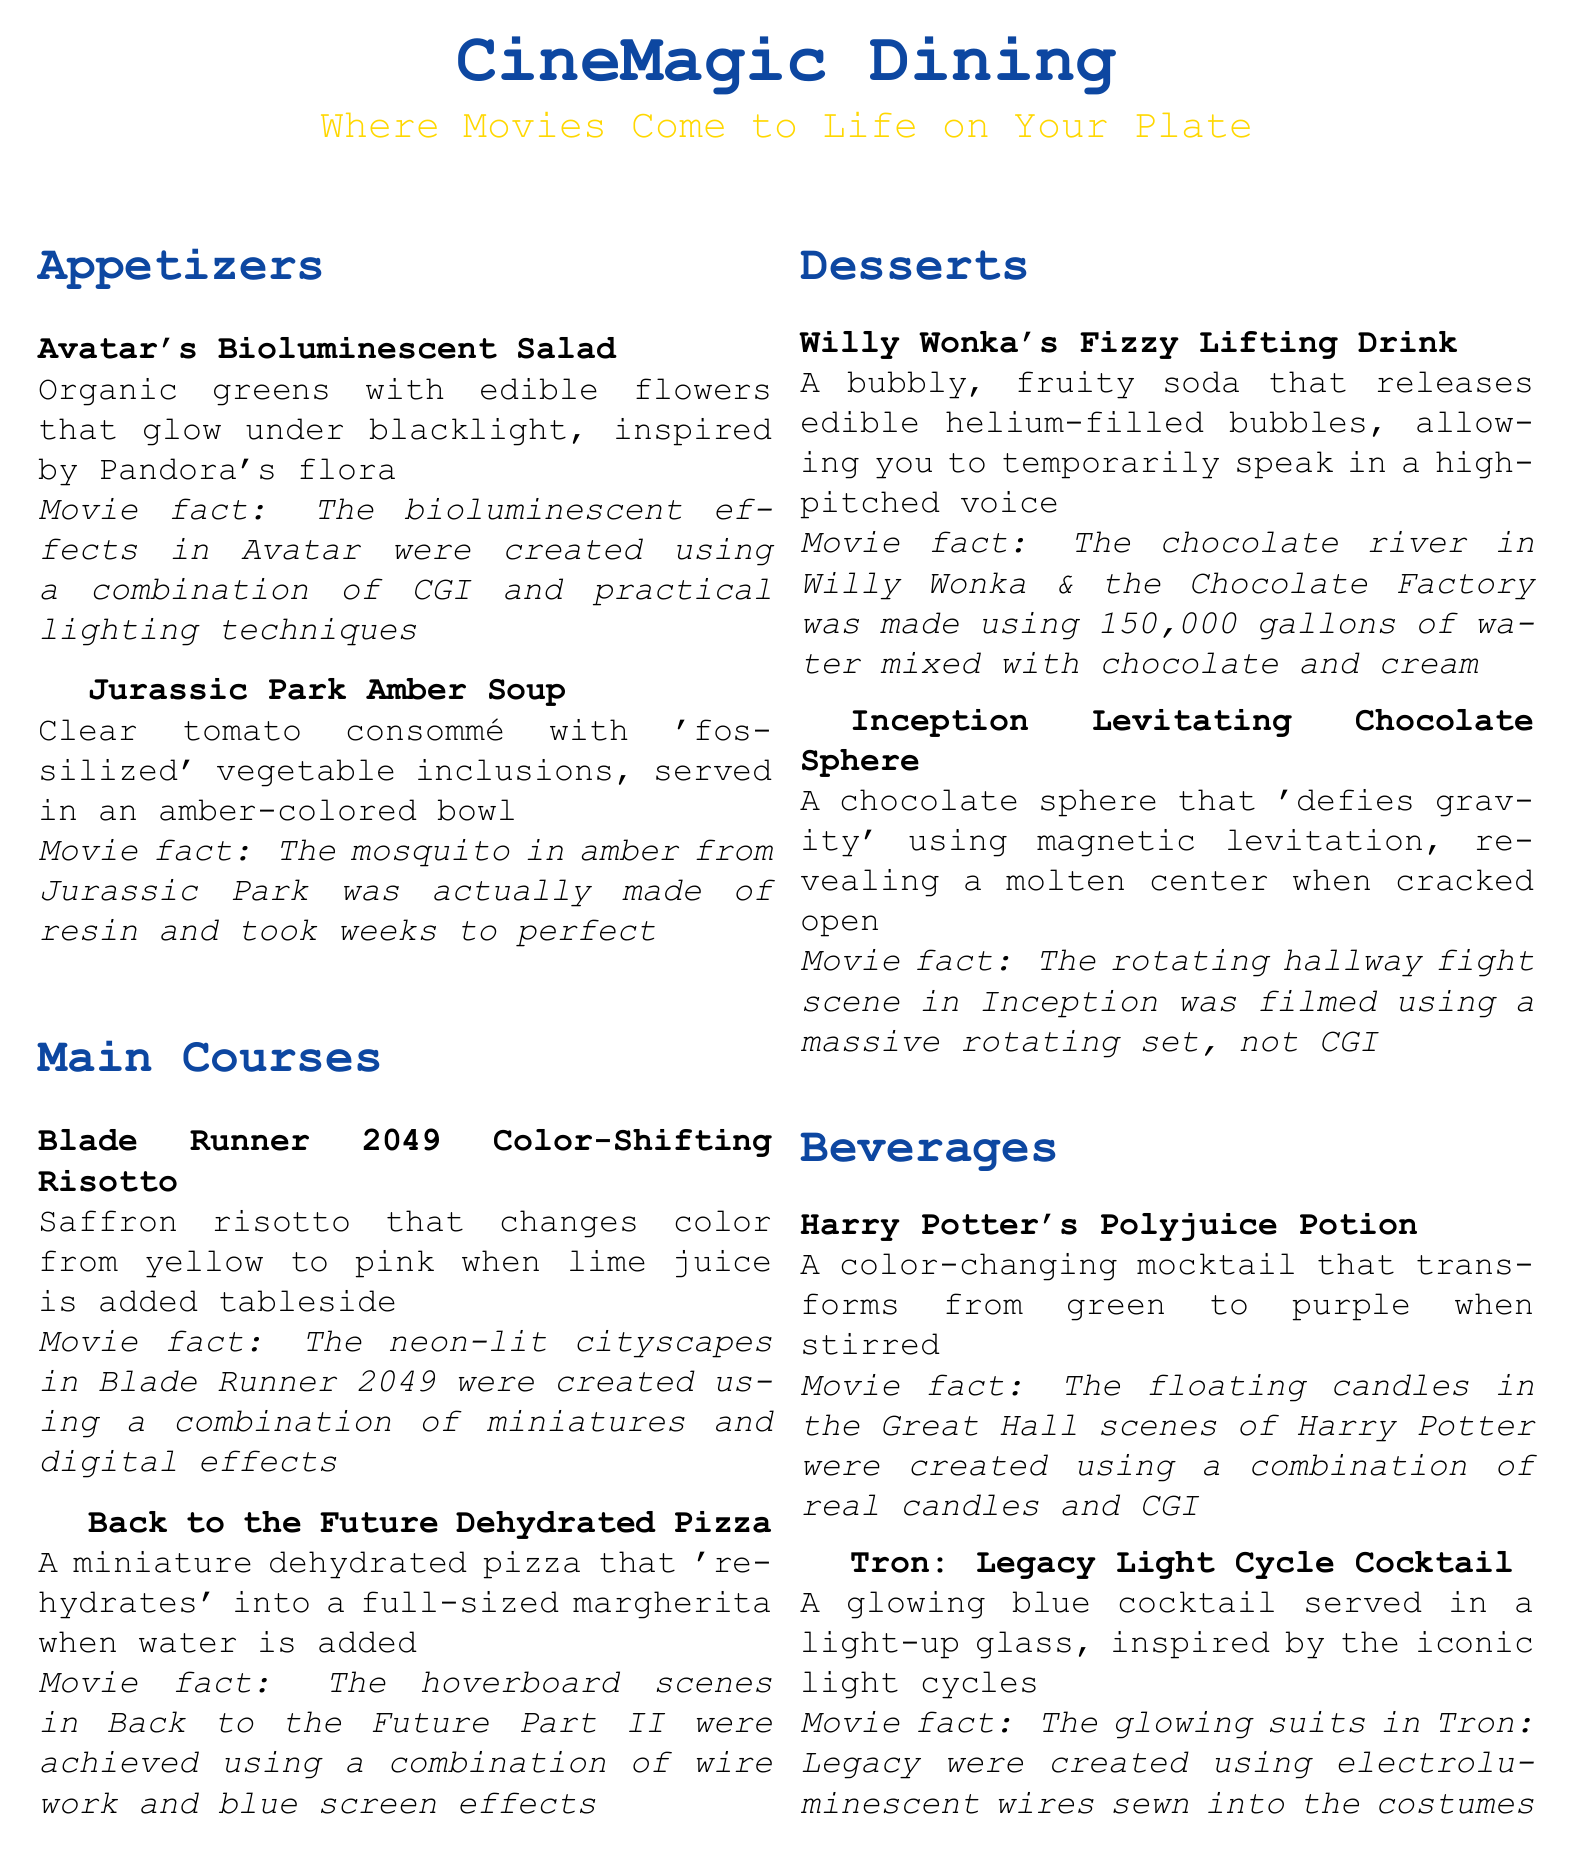What is the name of the appetizer inspired by Pandora? The appetizer is named "Avatar's Bioluminescent Salad," which features organic greens and edible flowers that glow under blacklight, inspired by Pandora's flora.
Answer: Avatar's Bioluminescent Salad What color does the "Blade Runner 2049 Color-Shifting Risotto" change to? The risotto changes color from yellow to pink when lime juice is added tableside.
Answer: Pink How does the "Back to the Future Dehydrated Pizza" transform? The dehydrated pizza 'rehydrates' into a full-sized margherita when water is added.
Answer: Rehydrates What notable movie effect was used in "Inception" to film the hallway fight scene? The hallmark effect utilized was a massive rotating set instead of CGI, providing a unique filming experience.
Answer: Massive rotating set What color does the "Harry Potter's Polyjuice Potion" mocktail change to? The mocktail transforms from green to purple when stirred, creating an engaging dining experience.
Answer: Purple How many gallons of water were used for the chocolate river in "Willy Wonka & the Chocolate Factory"? The river was made using 150,000 gallons of water mixed with chocolate and cream, showcasing an impressive production scale.
Answer: 150,000 gallons What kind of drink is "Willy Wonka's Fizzy Lifting Drink"? It is a bubbly, fruity soda that releases edible helium-filled bubbles, resulting in a temporary high-pitched voice when consumed.
Answer: Bubbly, fruity soda What visual technology was incorporated into the costumes in "Tron: Legacy"? The glowing suits utilized electroluminescent wires sewn into the costumes, enhancing the film's iconic visuals.
Answer: Electroluminescent wires Which dish features a magnetic levitation effect? The "Inception Levitating Chocolate Sphere" features magnetic levitation, creating a visually stunning dessert experience.
Answer: Inception Levitating Chocolate Sphere 